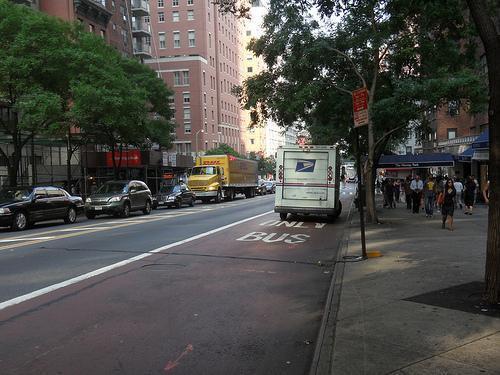How many yellow trucks on the street?
Give a very brief answer. 1. 